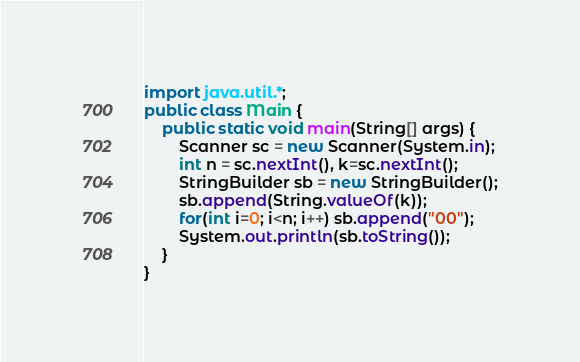Convert code to text. <code><loc_0><loc_0><loc_500><loc_500><_Java_>import java.util.*;
public class Main {
    public static void main(String[] args) {
        Scanner sc = new Scanner(System.in);
        int n = sc.nextInt(), k=sc.nextInt();
        StringBuilder sb = new StringBuilder();
        sb.append(String.valueOf(k));
        for(int i=0; i<n; i++) sb.append("00");
        System.out.println(sb.toString());
    }
}</code> 